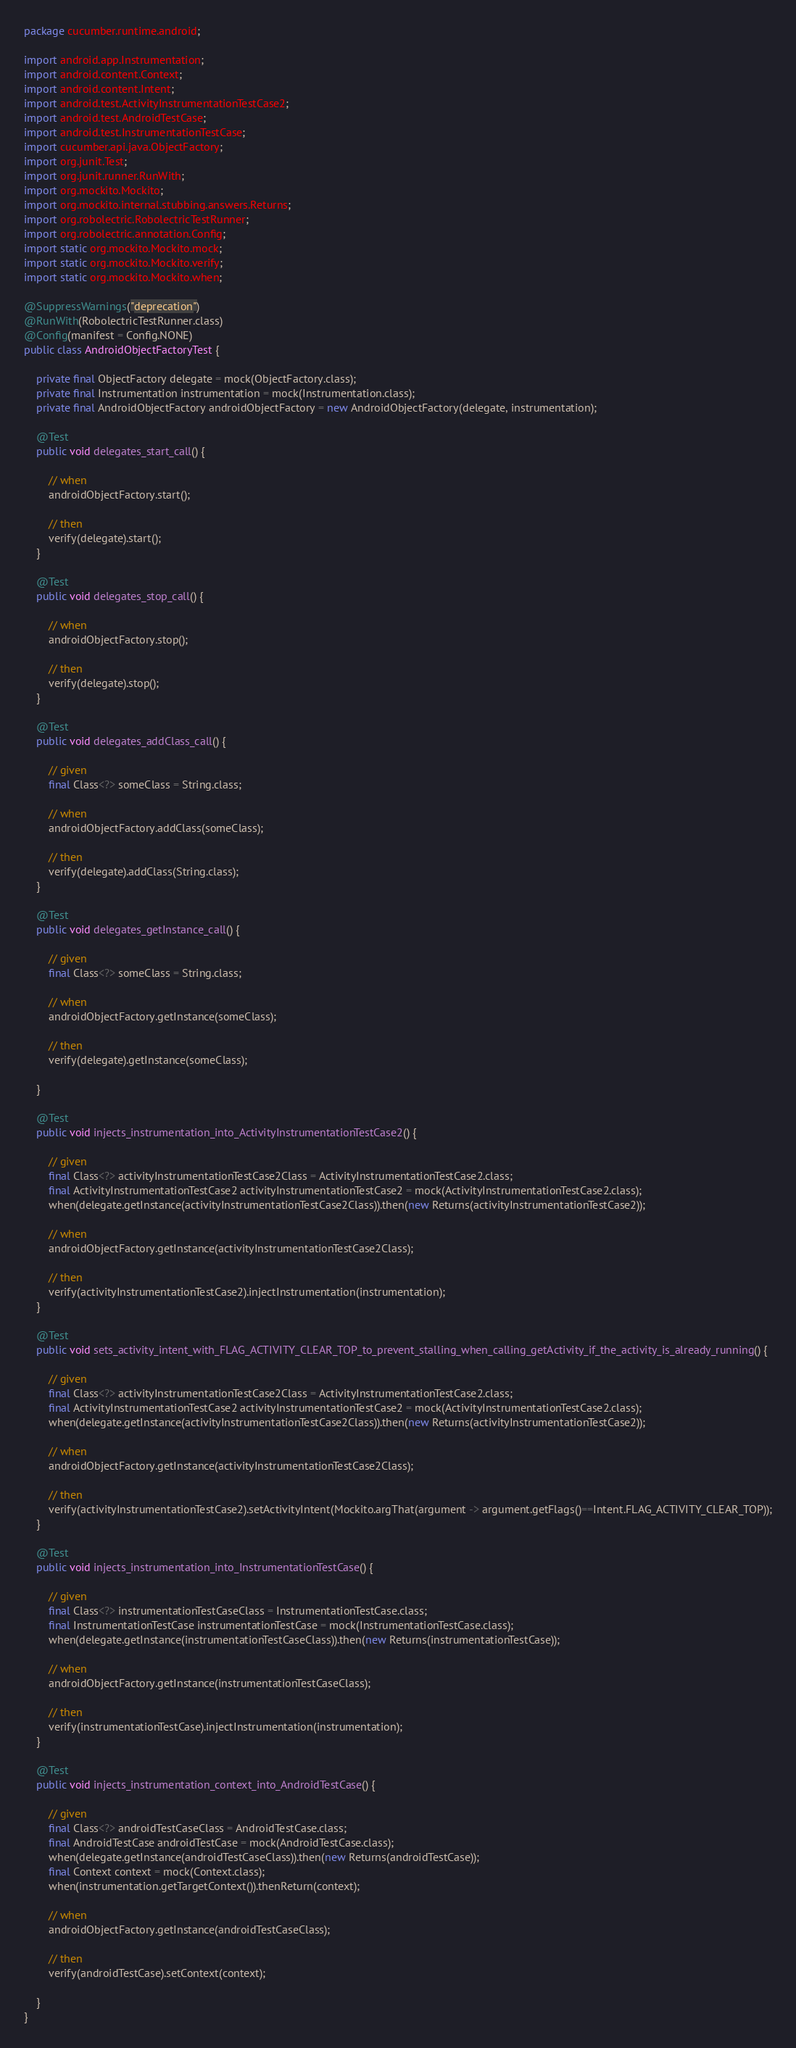Convert code to text. <code><loc_0><loc_0><loc_500><loc_500><_Java_>package cucumber.runtime.android;

import android.app.Instrumentation;
import android.content.Context;
import android.content.Intent;
import android.test.ActivityInstrumentationTestCase2;
import android.test.AndroidTestCase;
import android.test.InstrumentationTestCase;
import cucumber.api.java.ObjectFactory;
import org.junit.Test;
import org.junit.runner.RunWith;
import org.mockito.Mockito;
import org.mockito.internal.stubbing.answers.Returns;
import org.robolectric.RobolectricTestRunner;
import org.robolectric.annotation.Config;
import static org.mockito.Mockito.mock;
import static org.mockito.Mockito.verify;
import static org.mockito.Mockito.when;

@SuppressWarnings("deprecation")
@RunWith(RobolectricTestRunner.class)
@Config(manifest = Config.NONE)
public class AndroidObjectFactoryTest {

    private final ObjectFactory delegate = mock(ObjectFactory.class);
    private final Instrumentation instrumentation = mock(Instrumentation.class);
    private final AndroidObjectFactory androidObjectFactory = new AndroidObjectFactory(delegate, instrumentation);

    @Test
    public void delegates_start_call() {

        // when
        androidObjectFactory.start();

        // then
        verify(delegate).start();
    }

    @Test
    public void delegates_stop_call() {

        // when
        androidObjectFactory.stop();

        // then
        verify(delegate).stop();
    }

    @Test
    public void delegates_addClass_call() {

        // given
        final Class<?> someClass = String.class;

        // when
        androidObjectFactory.addClass(someClass);

        // then
        verify(delegate).addClass(String.class);
    }

    @Test
    public void delegates_getInstance_call() {

        // given
        final Class<?> someClass = String.class;

        // when
        androidObjectFactory.getInstance(someClass);

        // then
        verify(delegate).getInstance(someClass);

    }

    @Test
    public void injects_instrumentation_into_ActivityInstrumentationTestCase2() {

        // given
        final Class<?> activityInstrumentationTestCase2Class = ActivityInstrumentationTestCase2.class;
        final ActivityInstrumentationTestCase2 activityInstrumentationTestCase2 = mock(ActivityInstrumentationTestCase2.class);
        when(delegate.getInstance(activityInstrumentationTestCase2Class)).then(new Returns(activityInstrumentationTestCase2));

        // when
        androidObjectFactory.getInstance(activityInstrumentationTestCase2Class);

        // then
        verify(activityInstrumentationTestCase2).injectInstrumentation(instrumentation);
    }

    @Test
    public void sets_activity_intent_with_FLAG_ACTIVITY_CLEAR_TOP_to_prevent_stalling_when_calling_getActivity_if_the_activity_is_already_running() {

        // given
        final Class<?> activityInstrumentationTestCase2Class = ActivityInstrumentationTestCase2.class;
        final ActivityInstrumentationTestCase2 activityInstrumentationTestCase2 = mock(ActivityInstrumentationTestCase2.class);
        when(delegate.getInstance(activityInstrumentationTestCase2Class)).then(new Returns(activityInstrumentationTestCase2));

        // when
        androidObjectFactory.getInstance(activityInstrumentationTestCase2Class);

        // then
        verify(activityInstrumentationTestCase2).setActivityIntent(Mockito.argThat(argument -> argument.getFlags()==Intent.FLAG_ACTIVITY_CLEAR_TOP));
    }

    @Test
    public void injects_instrumentation_into_InstrumentationTestCase() {

        // given
        final Class<?> instrumentationTestCaseClass = InstrumentationTestCase.class;
        final InstrumentationTestCase instrumentationTestCase = mock(InstrumentationTestCase.class);
        when(delegate.getInstance(instrumentationTestCaseClass)).then(new Returns(instrumentationTestCase));

        // when
        androidObjectFactory.getInstance(instrumentationTestCaseClass);

        // then
        verify(instrumentationTestCase).injectInstrumentation(instrumentation);
    }

    @Test
    public void injects_instrumentation_context_into_AndroidTestCase() {

        // given
        final Class<?> androidTestCaseClass = AndroidTestCase.class;
        final AndroidTestCase androidTestCase = mock(AndroidTestCase.class);
        when(delegate.getInstance(androidTestCaseClass)).then(new Returns(androidTestCase));
        final Context context = mock(Context.class);
        when(instrumentation.getTargetContext()).thenReturn(context);

        // when
        androidObjectFactory.getInstance(androidTestCaseClass);

        // then
        verify(androidTestCase).setContext(context);

    }
}</code> 